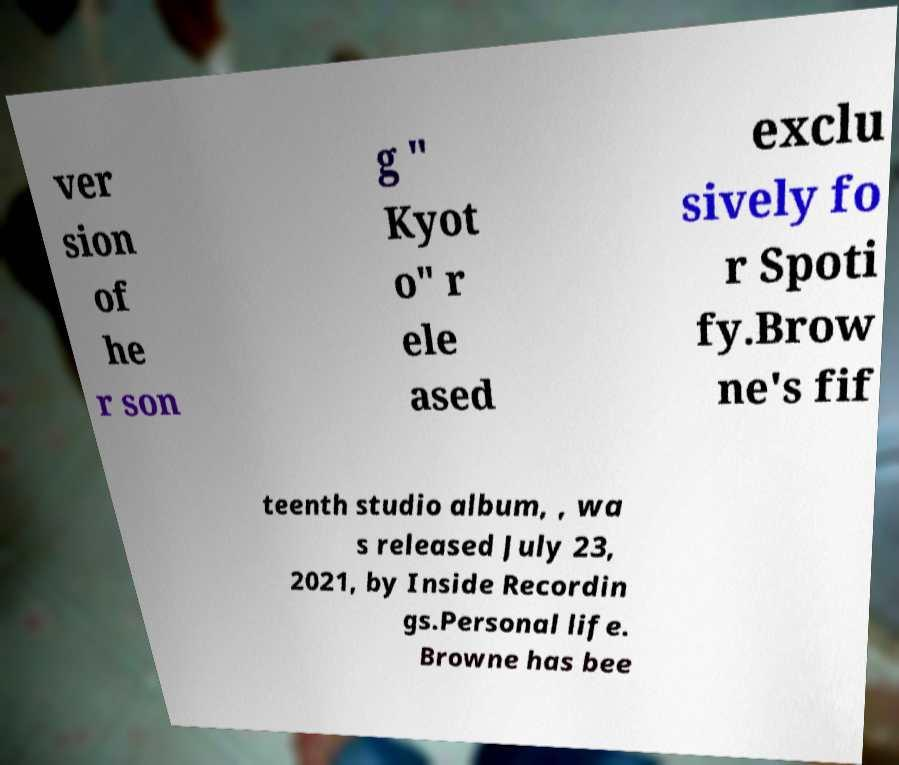What messages or text are displayed in this image? I need them in a readable, typed format. ver sion of he r son g " Kyot o" r ele ased exclu sively fo r Spoti fy.Brow ne's fif teenth studio album, , wa s released July 23, 2021, by Inside Recordin gs.Personal life. Browne has bee 